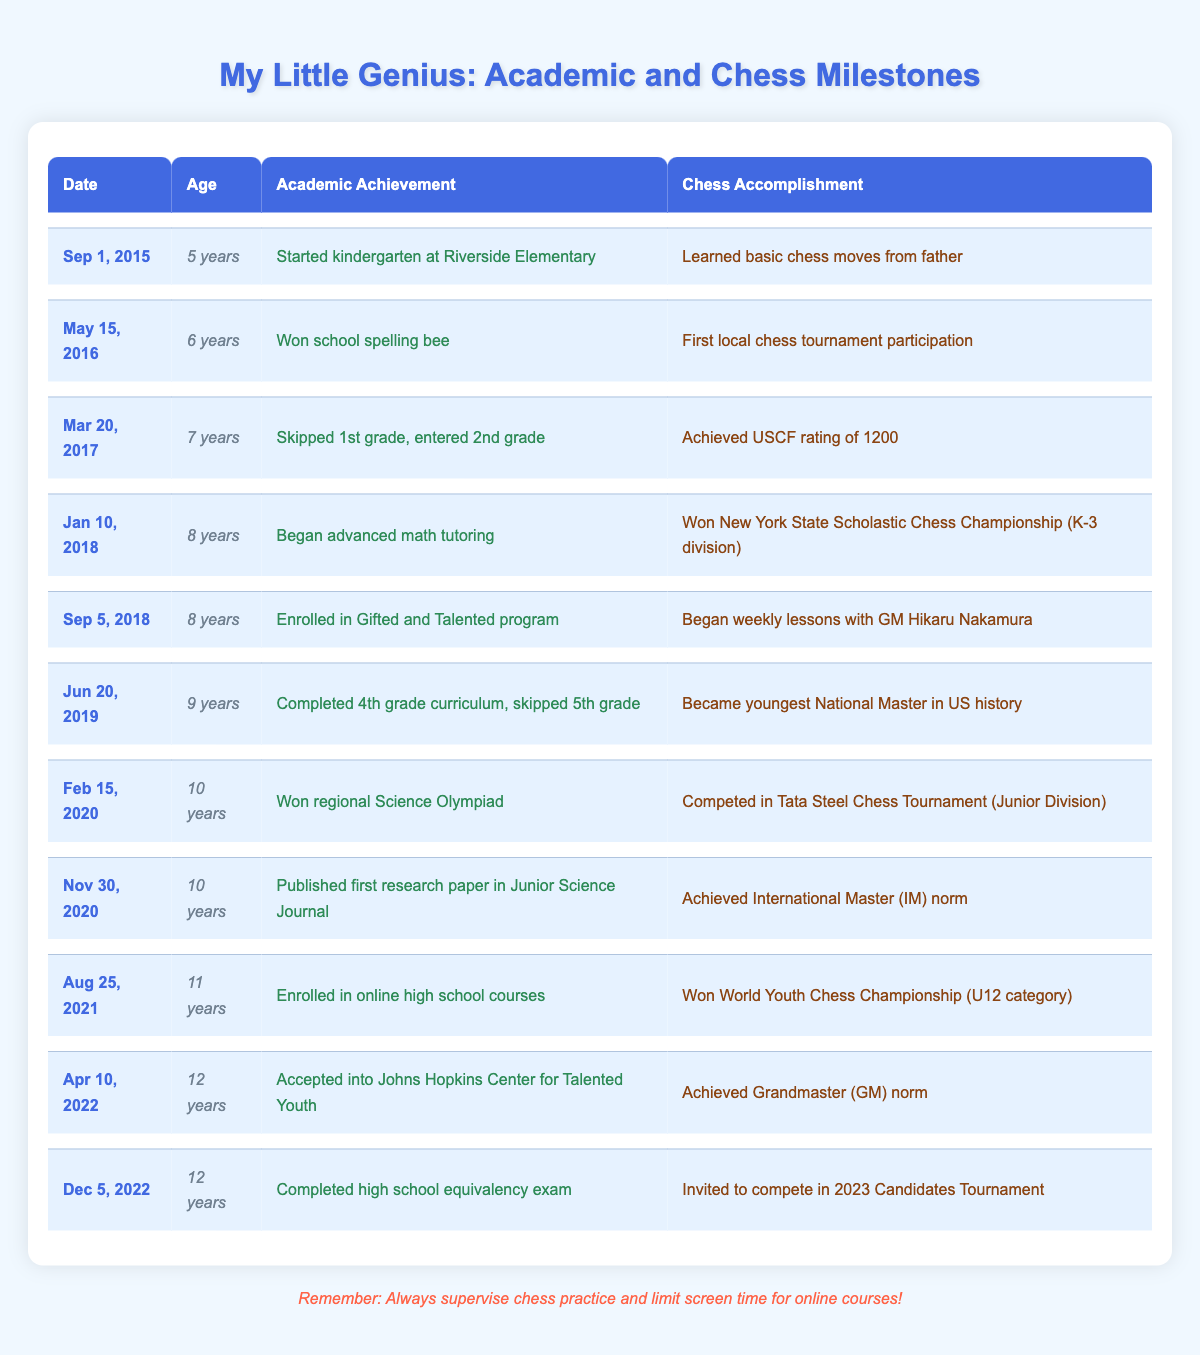What academic achievement did the child accomplish at age 8? At age 8, the child began advanced math tutoring, as stated in the timeline.
Answer: Began advanced math tutoring What was the chess accomplishment of the child when they turned 10? On February 15, 2020, at age 10, the child competed in the Tata Steel Chess Tournament (Junior Division).
Answer: Competed in Tata Steel Chess Tournament (Junior Division) What is the difference in age between when the child learned basic chess moves and when they became the youngest National Master? The child learned basic chess moves at age 5 and became the youngest National Master at age 9. The difference in age is 9 - 5 = 4 years.
Answer: 4 years Did the child win the World Youth Chess Championship before or after being accepted into Johns Hopkins Center for Talented Youth? The child won the World Youth Chess Championship on August 25, 2021, and was accepted into Johns Hopkins Center for Talented Youth on April 10, 2022, which indicates the championship win preceded acceptance into the program.
Answer: Before What two significant achievements did the child accomplish at age 12? At age 12, the child achieved the Grandmaster norm and completed the high school equivalency exam, both listed on April 10, 2022, and December 5, 2022, respectively.
Answer: Achieved Grandmaster norm and completed high school equivalency exam What was the child's chess accomplishment in November 2020? In November 2020, the child published their first research paper and achieved an International Master norm, as mentioned in the timeline under that date.
Answer: Achieved International Master (IM) norm 